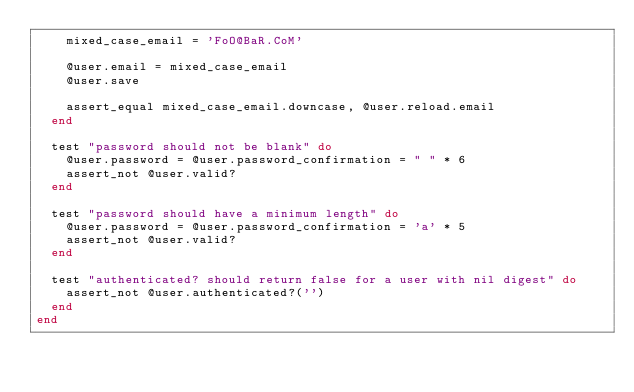<code> <loc_0><loc_0><loc_500><loc_500><_Ruby_>    mixed_case_email = 'FoO@BaR.CoM'

    @user.email = mixed_case_email
    @user.save

    assert_equal mixed_case_email.downcase, @user.reload.email
  end

  test "password should not be blank" do
    @user.password = @user.password_confirmation = " " * 6
    assert_not @user.valid?
  end

  test "password should have a minimum length" do
    @user.password = @user.password_confirmation = 'a' * 5
    assert_not @user.valid?
  end

  test "authenticated? should return false for a user with nil digest" do
    assert_not @user.authenticated?('')
  end
end
</code> 